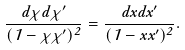Convert formula to latex. <formula><loc_0><loc_0><loc_500><loc_500>\frac { d \chi d \chi ^ { \prime } } { ( 1 - \chi \chi ^ { \prime } ) ^ { 2 } } = \frac { d x d x ^ { \prime } } { ( 1 - x x ^ { \prime } ) ^ { 2 } } .</formula> 